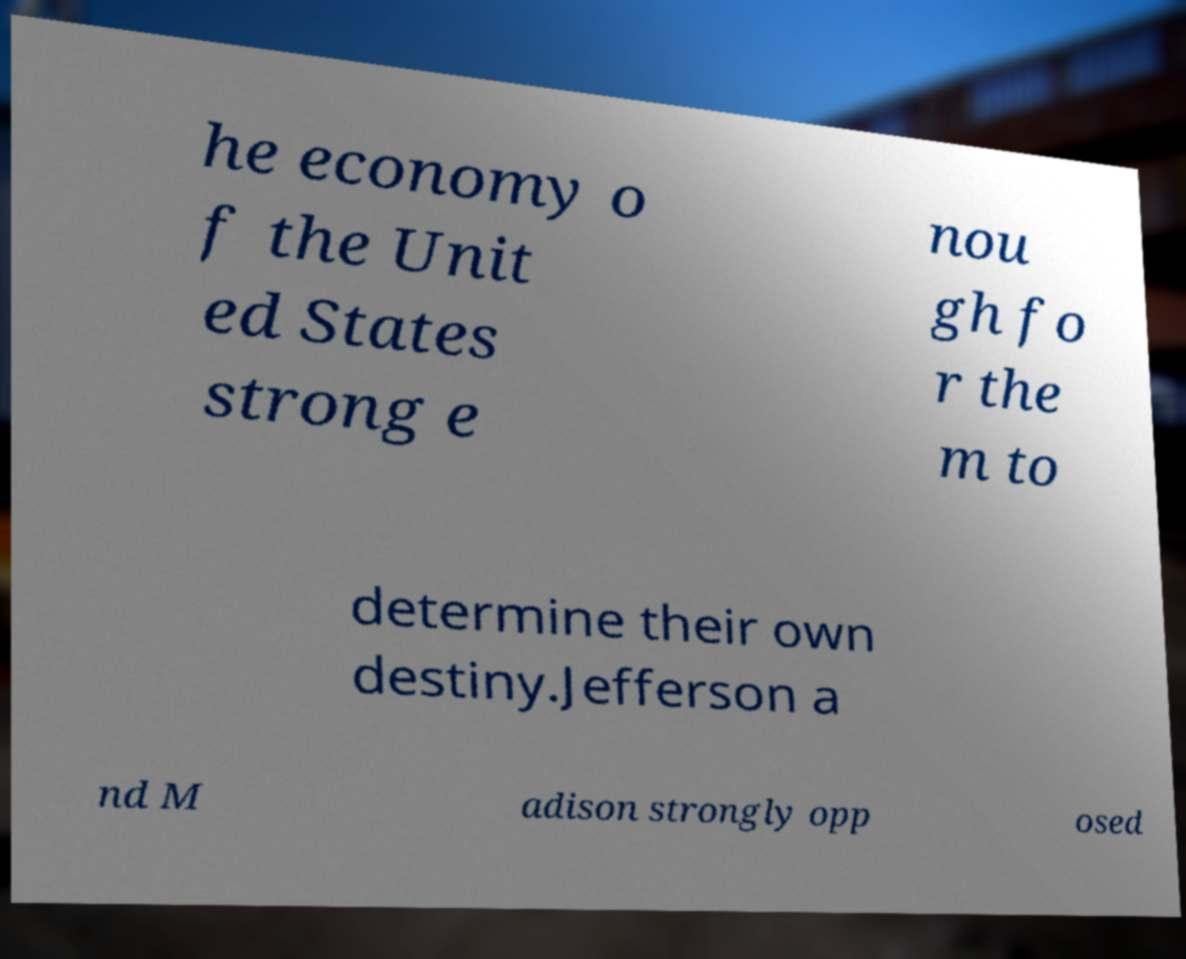Please identify and transcribe the text found in this image. he economy o f the Unit ed States strong e nou gh fo r the m to determine their own destiny.Jefferson a nd M adison strongly opp osed 